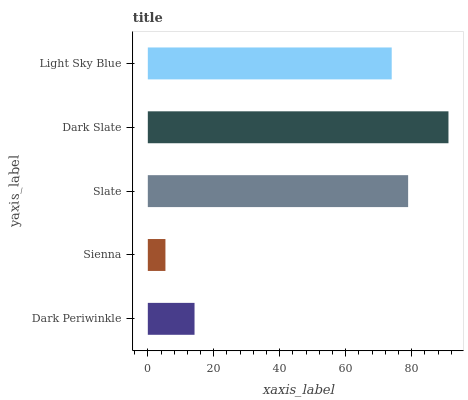Is Sienna the minimum?
Answer yes or no. Yes. Is Dark Slate the maximum?
Answer yes or no. Yes. Is Slate the minimum?
Answer yes or no. No. Is Slate the maximum?
Answer yes or no. No. Is Slate greater than Sienna?
Answer yes or no. Yes. Is Sienna less than Slate?
Answer yes or no. Yes. Is Sienna greater than Slate?
Answer yes or no. No. Is Slate less than Sienna?
Answer yes or no. No. Is Light Sky Blue the high median?
Answer yes or no. Yes. Is Light Sky Blue the low median?
Answer yes or no. Yes. Is Sienna the high median?
Answer yes or no. No. Is Slate the low median?
Answer yes or no. No. 